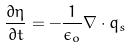<formula> <loc_0><loc_0><loc_500><loc_500>\frac { \partial \eta } { \partial t } = - \frac { 1 } { \epsilon _ { o } } \nabla \cdot q _ { s }</formula> 